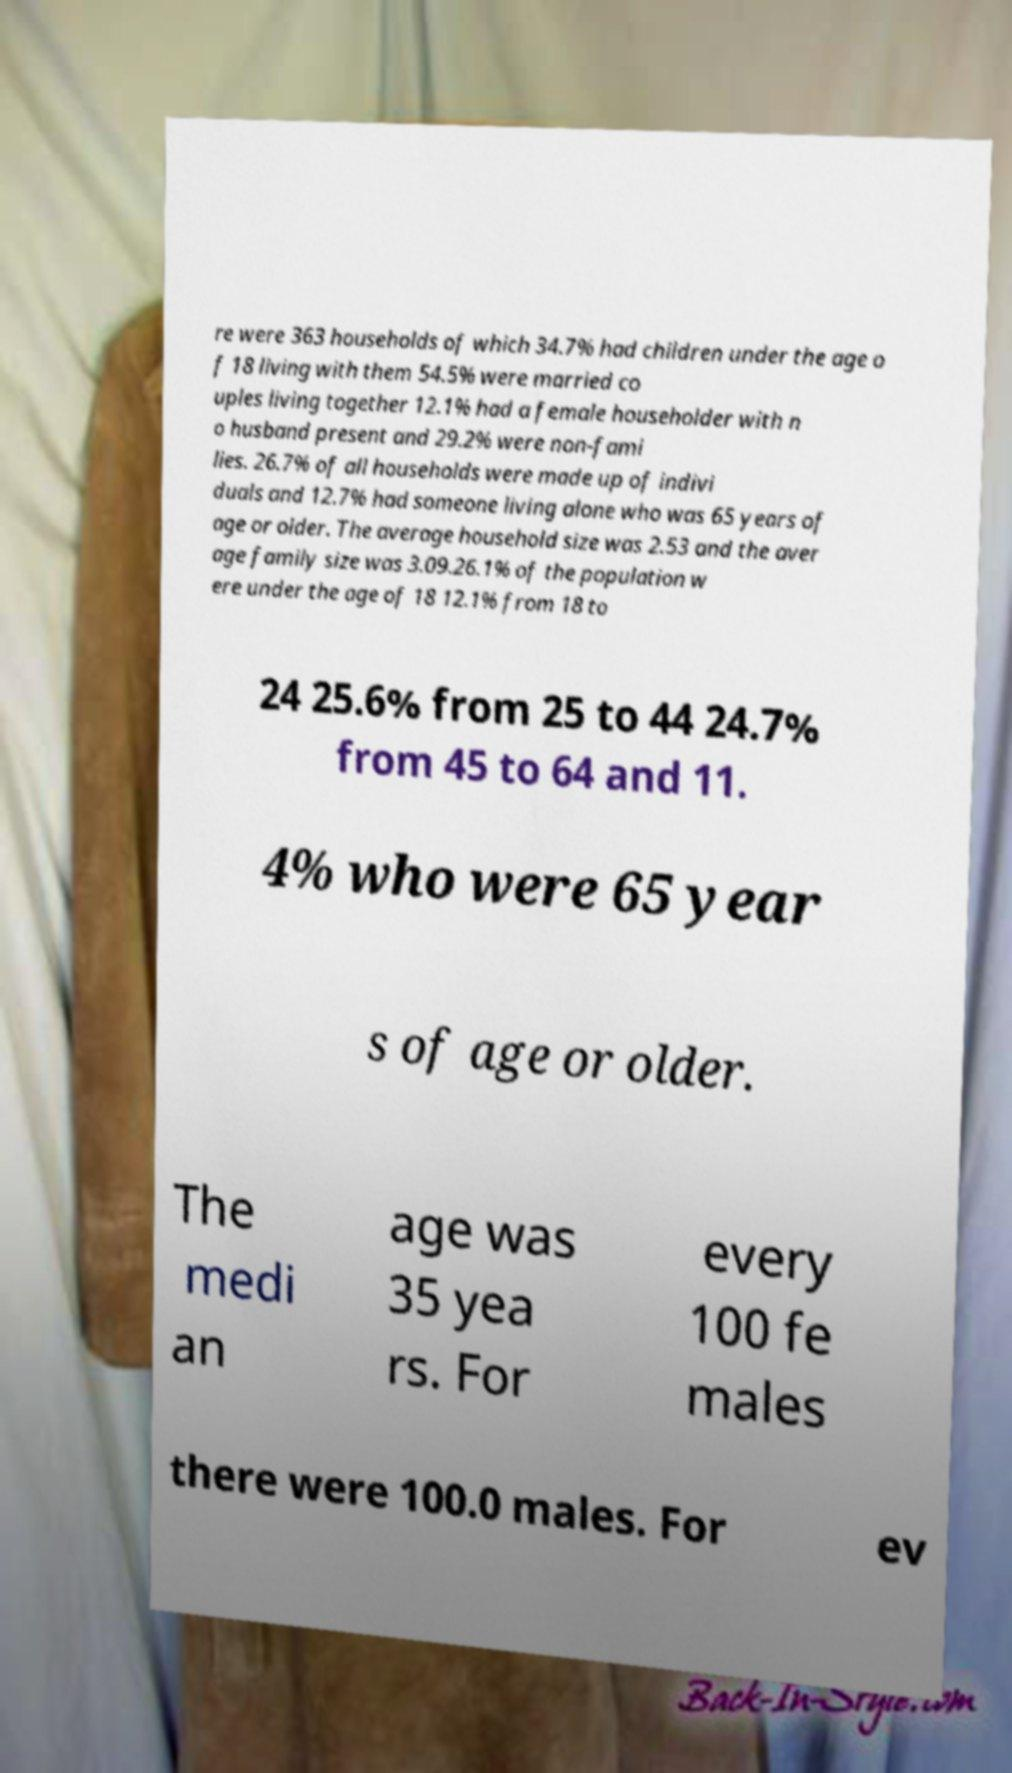Could you extract and type out the text from this image? re were 363 households of which 34.7% had children under the age o f 18 living with them 54.5% were married co uples living together 12.1% had a female householder with n o husband present and 29.2% were non-fami lies. 26.7% of all households were made up of indivi duals and 12.7% had someone living alone who was 65 years of age or older. The average household size was 2.53 and the aver age family size was 3.09.26.1% of the population w ere under the age of 18 12.1% from 18 to 24 25.6% from 25 to 44 24.7% from 45 to 64 and 11. 4% who were 65 year s of age or older. The medi an age was 35 yea rs. For every 100 fe males there were 100.0 males. For ev 